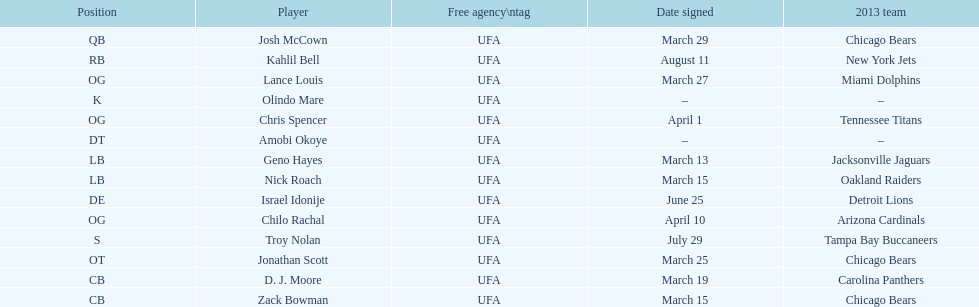How many free agents did this team pick up this season? 14. Could you parse the entire table as a dict? {'header': ['Position', 'Player', 'Free agency\\ntag', 'Date signed', '2013 team'], 'rows': [['QB', 'Josh McCown', 'UFA', 'March 29', 'Chicago Bears'], ['RB', 'Kahlil Bell', 'UFA', 'August 11', 'New York Jets'], ['OG', 'Lance Louis', 'UFA', 'March 27', 'Miami Dolphins'], ['K', 'Olindo Mare', 'UFA', '–', '–'], ['OG', 'Chris Spencer', 'UFA', 'April 1', 'Tennessee Titans'], ['DT', 'Amobi Okoye', 'UFA', '–', '–'], ['LB', 'Geno Hayes', 'UFA', 'March 13', 'Jacksonville Jaguars'], ['LB', 'Nick Roach', 'UFA', 'March 15', 'Oakland Raiders'], ['DE', 'Israel Idonije', 'UFA', 'June 25', 'Detroit Lions'], ['OG', 'Chilo Rachal', 'UFA', 'April 10', 'Arizona Cardinals'], ['S', 'Troy Nolan', 'UFA', 'July 29', 'Tampa Bay Buccaneers'], ['OT', 'Jonathan Scott', 'UFA', 'March 25', 'Chicago Bears'], ['CB', 'D. J. Moore', 'UFA', 'March 19', 'Carolina Panthers'], ['CB', 'Zack Bowman', 'UFA', 'March 15', 'Chicago Bears']]} 